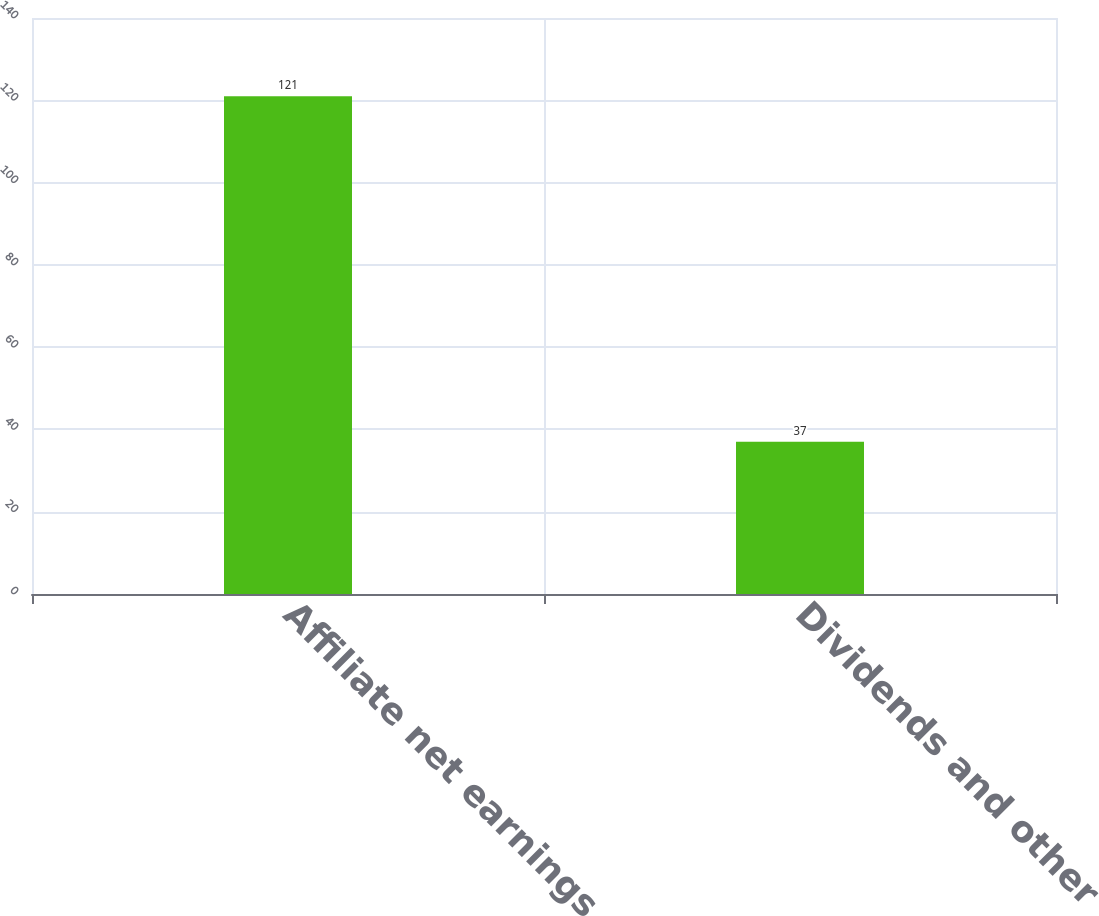<chart> <loc_0><loc_0><loc_500><loc_500><bar_chart><fcel>Affiliate net earnings<fcel>Dividends and other<nl><fcel>121<fcel>37<nl></chart> 